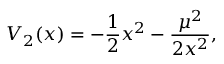<formula> <loc_0><loc_0><loc_500><loc_500>V _ { 2 } ( x ) = - { \frac { 1 } { 2 } } x ^ { 2 } - { \frac { \mu ^ { 2 } } { 2 x ^ { 2 } } } ,</formula> 